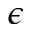<formula> <loc_0><loc_0><loc_500><loc_500>\epsilon</formula> 